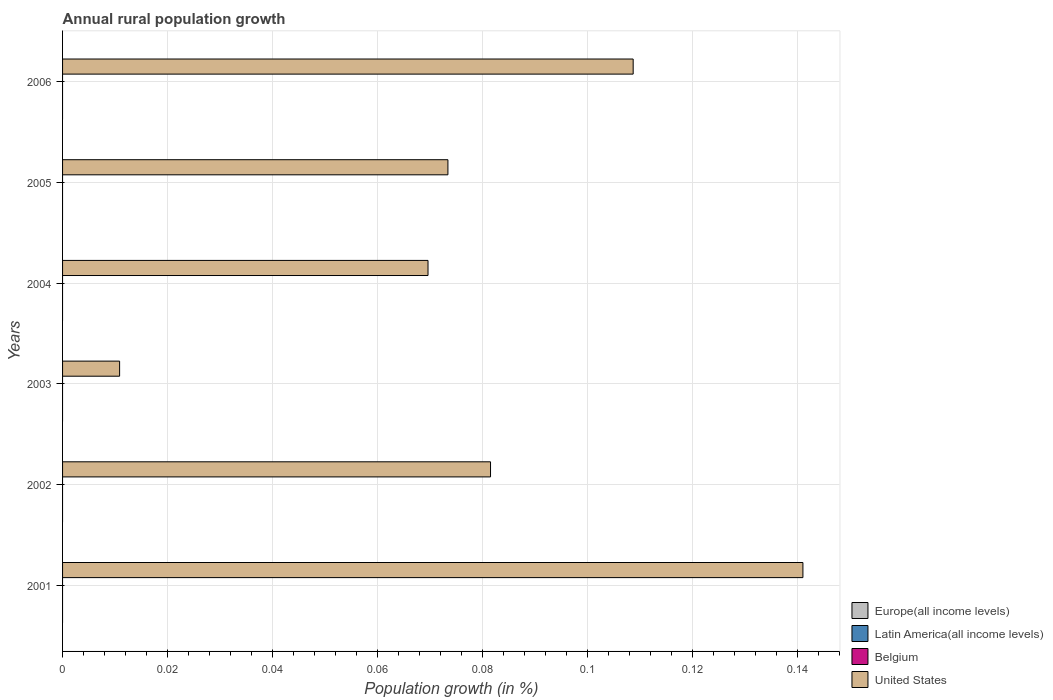Are the number of bars on each tick of the Y-axis equal?
Offer a terse response. Yes. How many bars are there on the 5th tick from the top?
Your answer should be compact. 1. How many bars are there on the 6th tick from the bottom?
Your answer should be compact. 1. What is the percentage of rural population growth in United States in 2003?
Offer a terse response. 0.01. Across all years, what is the minimum percentage of rural population growth in United States?
Make the answer very short. 0.01. What is the difference between the percentage of rural population growth in United States in 2002 and that in 2003?
Your answer should be very brief. 0.07. What is the difference between the percentage of rural population growth in Europe(all income levels) in 2004 and the percentage of rural population growth in United States in 2003?
Your answer should be very brief. -0.01. What is the ratio of the percentage of rural population growth in United States in 2001 to that in 2005?
Your response must be concise. 1.92. What is the difference between the highest and the second highest percentage of rural population growth in United States?
Provide a succinct answer. 0.03. What is the difference between the highest and the lowest percentage of rural population growth in United States?
Your answer should be compact. 0.13. Are all the bars in the graph horizontal?
Offer a very short reply. Yes. What is the difference between two consecutive major ticks on the X-axis?
Make the answer very short. 0.02. Does the graph contain grids?
Offer a very short reply. Yes. How many legend labels are there?
Provide a short and direct response. 4. What is the title of the graph?
Ensure brevity in your answer.  Annual rural population growth. What is the label or title of the X-axis?
Your response must be concise. Population growth (in %). What is the label or title of the Y-axis?
Offer a very short reply. Years. What is the Population growth (in %) of Latin America(all income levels) in 2001?
Provide a succinct answer. 0. What is the Population growth (in %) in United States in 2001?
Ensure brevity in your answer.  0.14. What is the Population growth (in %) in Europe(all income levels) in 2002?
Offer a terse response. 0. What is the Population growth (in %) of Latin America(all income levels) in 2002?
Offer a very short reply. 0. What is the Population growth (in %) in United States in 2002?
Make the answer very short. 0.08. What is the Population growth (in %) in United States in 2003?
Offer a terse response. 0.01. What is the Population growth (in %) of Europe(all income levels) in 2004?
Ensure brevity in your answer.  0. What is the Population growth (in %) of Latin America(all income levels) in 2004?
Your response must be concise. 0. What is the Population growth (in %) in Belgium in 2004?
Your answer should be very brief. 0. What is the Population growth (in %) of United States in 2004?
Provide a short and direct response. 0.07. What is the Population growth (in %) of Latin America(all income levels) in 2005?
Your answer should be compact. 0. What is the Population growth (in %) in Belgium in 2005?
Your answer should be compact. 0. What is the Population growth (in %) in United States in 2005?
Your response must be concise. 0.07. What is the Population growth (in %) in Europe(all income levels) in 2006?
Ensure brevity in your answer.  0. What is the Population growth (in %) in United States in 2006?
Offer a very short reply. 0.11. Across all years, what is the maximum Population growth (in %) in United States?
Keep it short and to the point. 0.14. Across all years, what is the minimum Population growth (in %) of United States?
Offer a very short reply. 0.01. What is the total Population growth (in %) in Latin America(all income levels) in the graph?
Provide a succinct answer. 0. What is the total Population growth (in %) of United States in the graph?
Make the answer very short. 0.48. What is the difference between the Population growth (in %) of United States in 2001 and that in 2002?
Make the answer very short. 0.06. What is the difference between the Population growth (in %) of United States in 2001 and that in 2003?
Provide a succinct answer. 0.13. What is the difference between the Population growth (in %) of United States in 2001 and that in 2004?
Provide a succinct answer. 0.07. What is the difference between the Population growth (in %) of United States in 2001 and that in 2005?
Offer a very short reply. 0.07. What is the difference between the Population growth (in %) of United States in 2001 and that in 2006?
Your response must be concise. 0.03. What is the difference between the Population growth (in %) of United States in 2002 and that in 2003?
Keep it short and to the point. 0.07. What is the difference between the Population growth (in %) in United States in 2002 and that in 2004?
Your response must be concise. 0.01. What is the difference between the Population growth (in %) in United States in 2002 and that in 2005?
Your answer should be very brief. 0.01. What is the difference between the Population growth (in %) in United States in 2002 and that in 2006?
Provide a succinct answer. -0.03. What is the difference between the Population growth (in %) in United States in 2003 and that in 2004?
Your response must be concise. -0.06. What is the difference between the Population growth (in %) in United States in 2003 and that in 2005?
Ensure brevity in your answer.  -0.06. What is the difference between the Population growth (in %) of United States in 2003 and that in 2006?
Ensure brevity in your answer.  -0.1. What is the difference between the Population growth (in %) in United States in 2004 and that in 2005?
Provide a short and direct response. -0. What is the difference between the Population growth (in %) in United States in 2004 and that in 2006?
Your response must be concise. -0.04. What is the difference between the Population growth (in %) in United States in 2005 and that in 2006?
Provide a short and direct response. -0.04. What is the average Population growth (in %) of Europe(all income levels) per year?
Your answer should be very brief. 0. What is the average Population growth (in %) of Latin America(all income levels) per year?
Provide a short and direct response. 0. What is the average Population growth (in %) of Belgium per year?
Keep it short and to the point. 0. What is the average Population growth (in %) of United States per year?
Keep it short and to the point. 0.08. What is the ratio of the Population growth (in %) in United States in 2001 to that in 2002?
Ensure brevity in your answer.  1.73. What is the ratio of the Population growth (in %) in United States in 2001 to that in 2003?
Provide a short and direct response. 12.98. What is the ratio of the Population growth (in %) of United States in 2001 to that in 2004?
Provide a short and direct response. 2.03. What is the ratio of the Population growth (in %) of United States in 2001 to that in 2005?
Provide a succinct answer. 1.92. What is the ratio of the Population growth (in %) of United States in 2001 to that in 2006?
Ensure brevity in your answer.  1.3. What is the ratio of the Population growth (in %) of United States in 2002 to that in 2003?
Offer a very short reply. 7.5. What is the ratio of the Population growth (in %) in United States in 2002 to that in 2004?
Keep it short and to the point. 1.17. What is the ratio of the Population growth (in %) of United States in 2002 to that in 2005?
Provide a succinct answer. 1.11. What is the ratio of the Population growth (in %) in United States in 2002 to that in 2006?
Your answer should be compact. 0.75. What is the ratio of the Population growth (in %) of United States in 2003 to that in 2004?
Ensure brevity in your answer.  0.16. What is the ratio of the Population growth (in %) of United States in 2003 to that in 2005?
Your answer should be compact. 0.15. What is the ratio of the Population growth (in %) in United States in 2003 to that in 2006?
Offer a very short reply. 0.1. What is the ratio of the Population growth (in %) in United States in 2004 to that in 2005?
Provide a short and direct response. 0.95. What is the ratio of the Population growth (in %) in United States in 2004 to that in 2006?
Give a very brief answer. 0.64. What is the ratio of the Population growth (in %) in United States in 2005 to that in 2006?
Your response must be concise. 0.68. What is the difference between the highest and the second highest Population growth (in %) of United States?
Provide a short and direct response. 0.03. What is the difference between the highest and the lowest Population growth (in %) of United States?
Offer a terse response. 0.13. 